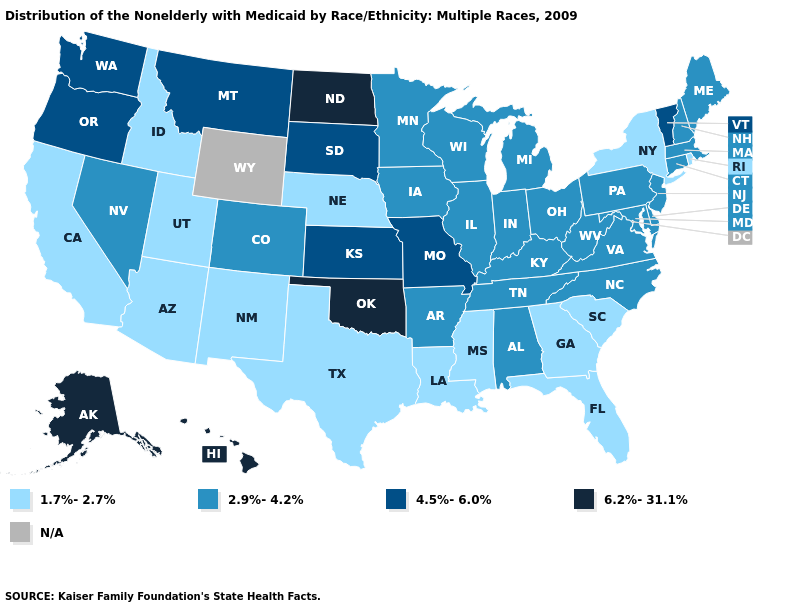What is the highest value in the USA?
Short answer required. 6.2%-31.1%. Name the states that have a value in the range 2.9%-4.2%?
Write a very short answer. Alabama, Arkansas, Colorado, Connecticut, Delaware, Illinois, Indiana, Iowa, Kentucky, Maine, Maryland, Massachusetts, Michigan, Minnesota, Nevada, New Hampshire, New Jersey, North Carolina, Ohio, Pennsylvania, Tennessee, Virginia, West Virginia, Wisconsin. What is the highest value in the West ?
Short answer required. 6.2%-31.1%. Among the states that border New Mexico , does Utah have the highest value?
Write a very short answer. No. Does Hawaii have the highest value in the USA?
Answer briefly. Yes. Does the map have missing data?
Keep it brief. Yes. What is the value of Indiana?
Write a very short answer. 2.9%-4.2%. Which states hav the highest value in the West?
Short answer required. Alaska, Hawaii. What is the value of Utah?
Concise answer only. 1.7%-2.7%. Name the states that have a value in the range 6.2%-31.1%?
Give a very brief answer. Alaska, Hawaii, North Dakota, Oklahoma. Name the states that have a value in the range N/A?
Write a very short answer. Wyoming. What is the lowest value in the West?
Keep it brief. 1.7%-2.7%. Is the legend a continuous bar?
Answer briefly. No. What is the value of New York?
Concise answer only. 1.7%-2.7%. 